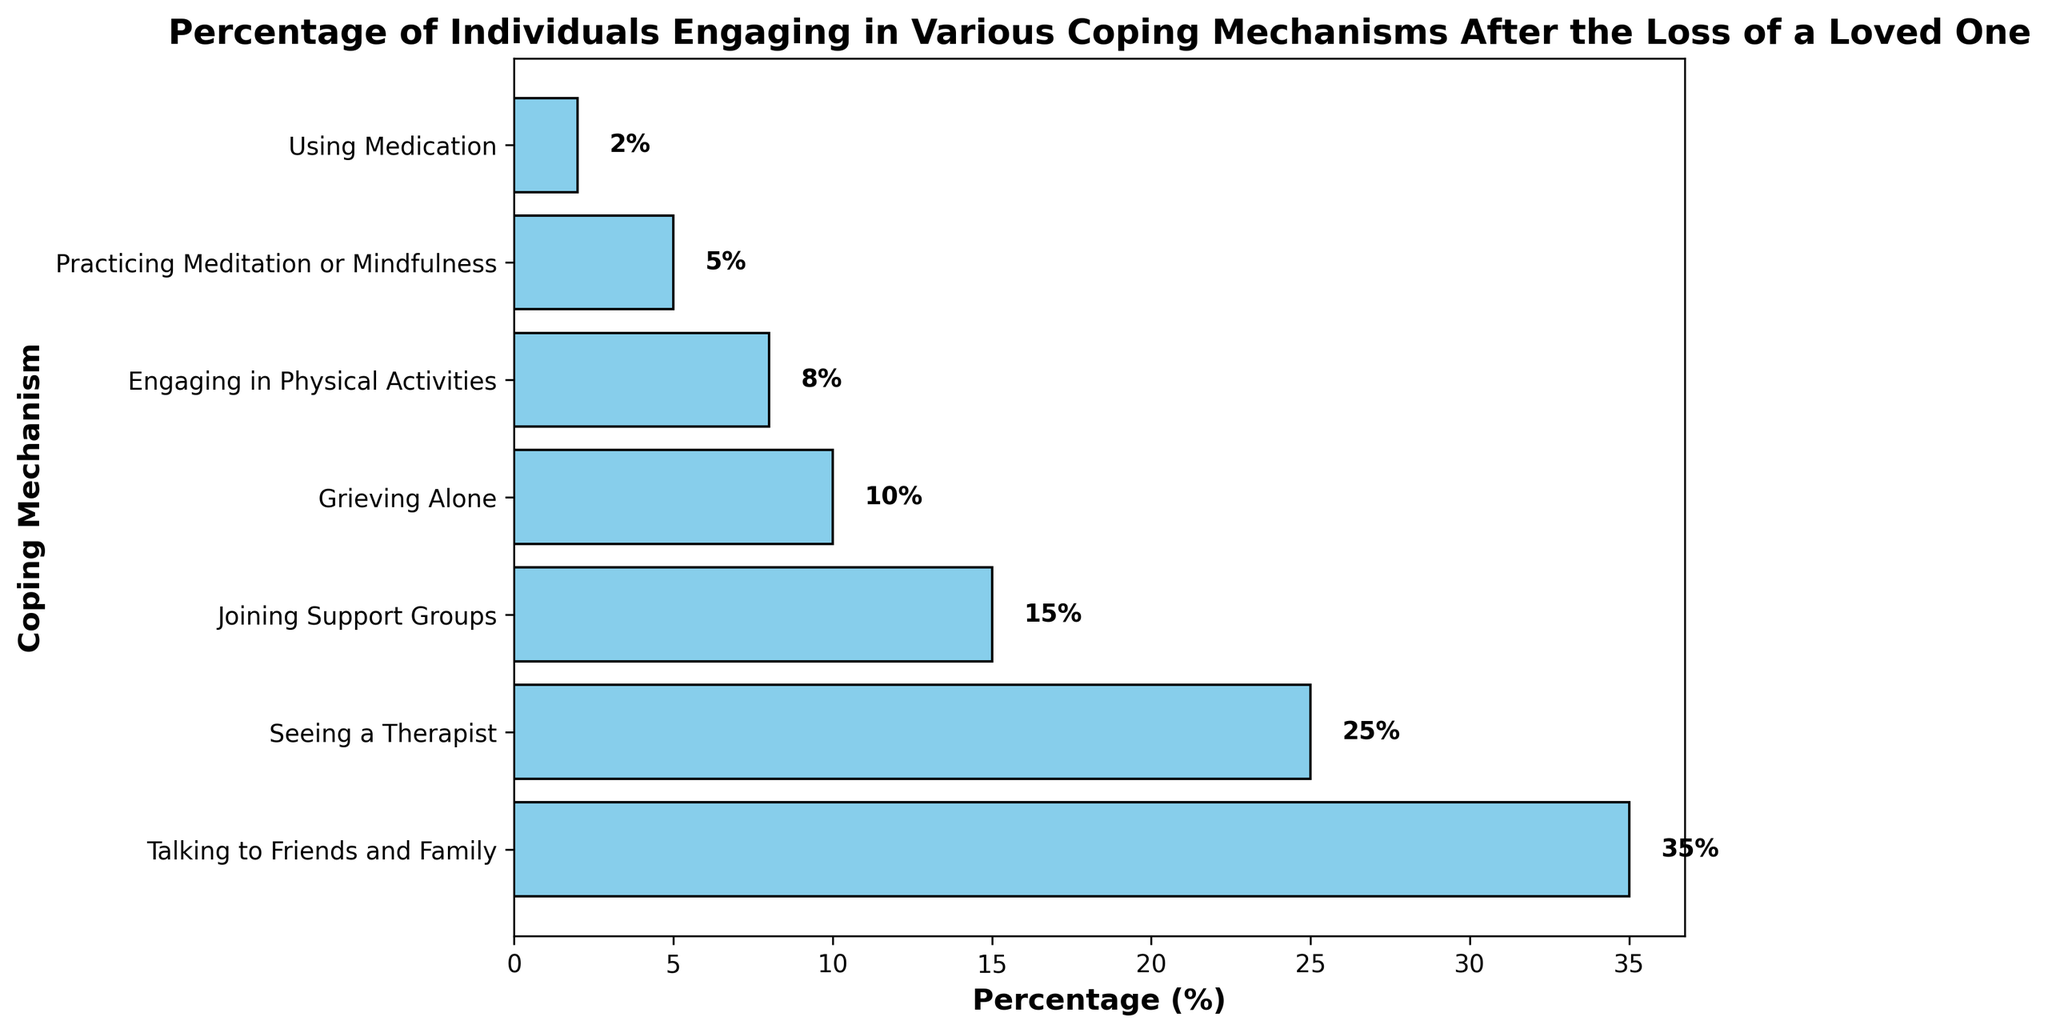Which coping mechanism is used the most by individuals? The bar representing "Talking to Friends and Family" is the longest, reaching 35%.
Answer: Talking to Friends and Family Which coping mechanism is the least common among individuals? The bar representing "Using Medication" is the shortest, only reaching 2%.
Answer: Using Medication By how much percentage is "Seeing a Therapist" more common than "Engaging in Physical Activities"? "Seeing a Therapist" is at 25% while "Engaging in Physical Activities" is at 8%. The difference is 25% - 8% = 17%.
Answer: 17% What is the combined percentage of individuals practicing "Meditation or Mindfulness" and "Using Medication"? "Practicing Meditation or Mindfulness" is at 5% and "Using Medication" is at 2%. The combined percentage is 5% + 2% = 7%.
Answer: 7% Which coping mechanisms have percentages greater than 10%? The bars representing "Talking to Friends and Family" (35%), "Seeing a Therapist" (25%), "Joining Support Groups" (15%), and "Grieving Alone" (10%) are all greater than 10%.
Answer: Talking to Friends and Family, Seeing a Therapist, Joining Support Groups How much more common is "Talking to Friends and Family" compared to "Grieving Alone"? "Talking to Friends and Family" is at 35% while "Grieving Alone" is at 10%. The difference is 35% - 10% = 25%.
Answer: 25% What is the difference in percentage between the highest and lowest coping mechanisms? The highest percentage is "Talking to Friends and Family" at 35% and the lowest is "Using Medication" at 2%. The difference is 35% - 2% = 33%.
Answer: 33% What is the average percentage of all coping mechanisms? Sum all the percentages: 35 + 25 + 15 + 10 + 8 + 5 + 2 = 100. There are 7 coping mechanisms, so the average is 100/7 ≈ 14.29%.
Answer: 14.29% How many coping mechanisms have a percentage less than 10%? "Engaging in Physical Activities" (8%), "Practicing Meditation or Mindfulness" (5%), and "Using Medication" (2%) are less than 10%. There are 3 such coping mechanisms.
Answer: 3 